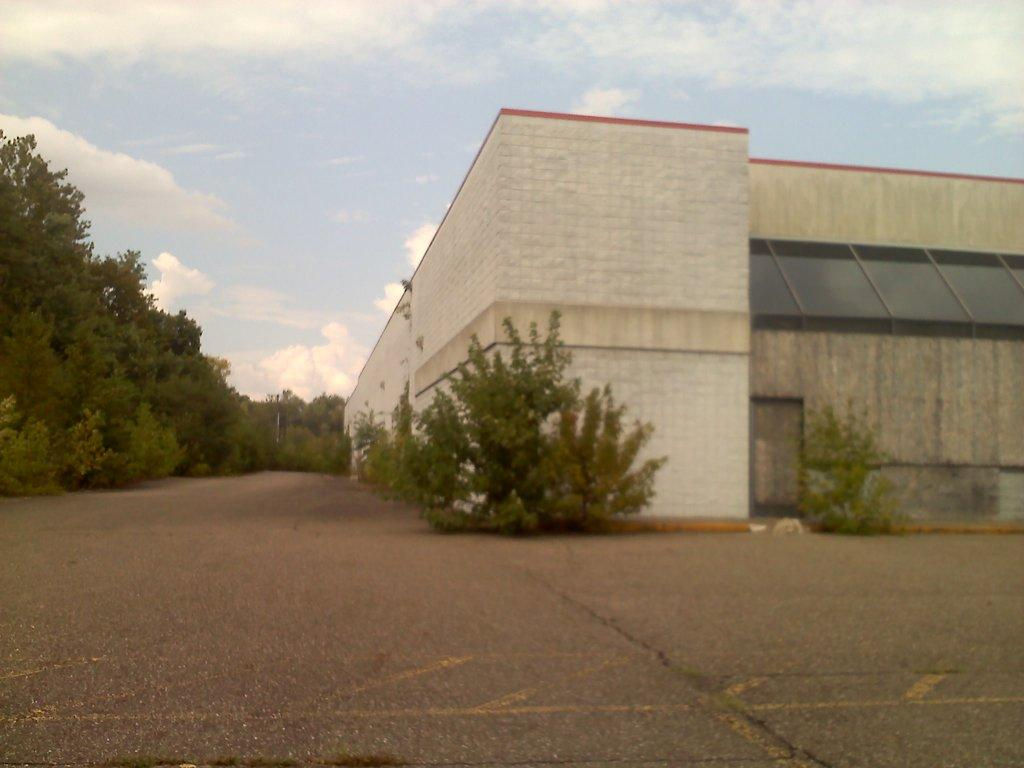What type of man-made structure can be seen in the image? There is a factory in the image. What is the primary mode of transportation visible in the image? There is a road in the image, which is a common mode of transportation. What type of vegetation is on the left side of the image? There are trees on the left side of the image. What type of vegetation is on the right side of the image? There are plants on the right side of the image. What is visible at the top of the image? The sky is clear and visible at the top of the image. Can you see a monkey climbing the trees on the left side of the image? There is no monkey present in the image; only trees are visible on the left side. Is there a ship sailing on the road in the image? There is no ship present in the image, and the road is not a body of water for a ship to sail on. 